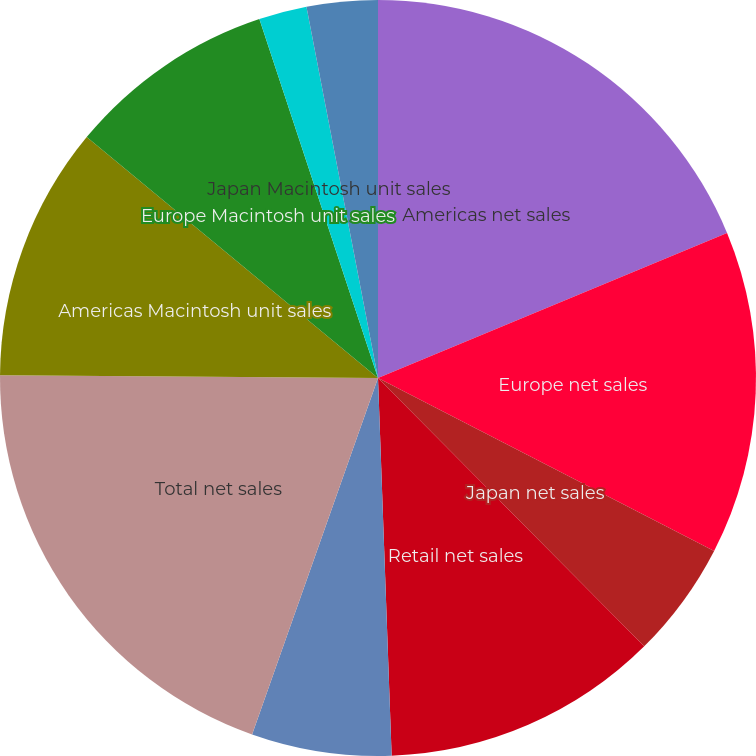<chart> <loc_0><loc_0><loc_500><loc_500><pie_chart><fcel>Americas net sales<fcel>Europe net sales<fcel>Japan net sales<fcel>Retail net sales<fcel>Other Segments net sales (a)<fcel>Total net sales<fcel>Americas Macintosh unit sales<fcel>Europe Macintosh unit sales<fcel>Japan Macintosh unit sales<fcel>Retail Macintosh unit sales<nl><fcel>18.73%<fcel>13.83%<fcel>5.0%<fcel>11.86%<fcel>5.98%<fcel>19.71%<fcel>10.88%<fcel>8.92%<fcel>2.05%<fcel>3.03%<nl></chart> 